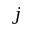<formula> <loc_0><loc_0><loc_500><loc_500>j</formula> 